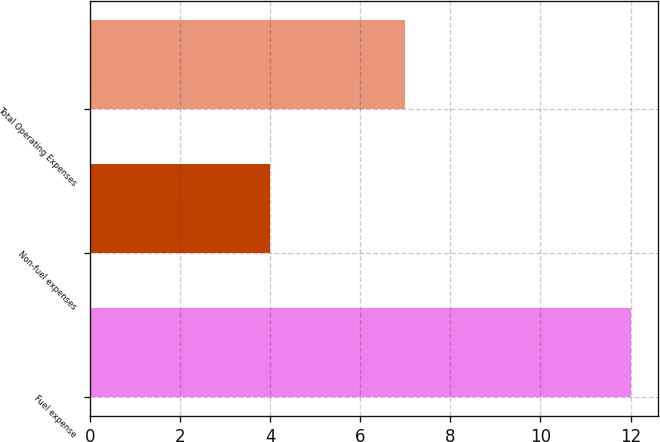Convert chart to OTSL. <chart><loc_0><loc_0><loc_500><loc_500><bar_chart><fcel>Fuel expense<fcel>Non-fuel expenses<fcel>Total Operating Expenses<nl><fcel>12<fcel>4<fcel>7<nl></chart> 